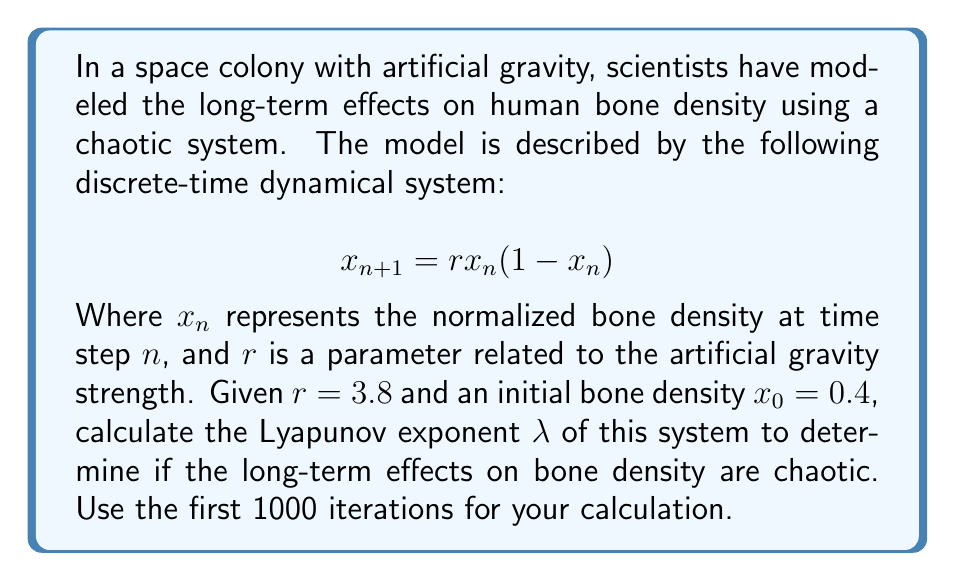Can you solve this math problem? To calculate the Lyapunov exponent λ for this system, we'll follow these steps:

1) The Lyapunov exponent is given by:

   $$λ = \lim_{N \to \infty} \frac{1}{N} \sum_{n=0}^{N-1} \ln|f'(x_n)|$$

   Where $f'(x_n)$ is the derivative of the system's function evaluated at $x_n$.

2) For our system, $f(x) = rx(1-x)$, so $f'(x) = r(1-2x)$

3) We need to iterate the system and sum the logarithms of the absolute values of $f'(x_n)$:

   $$x_{n+1} = 3.8x_n(1-x_n)$$
   $$\ln|f'(x_n)| = \ln|3.8(1-2x_n)|$$

4) Let's calculate the first few iterations:
   
   $x_0 = 0.4$
   $x_1 = 3.8 * 0.4 * (1-0.4) = 0.912$
   $x_2 = 3.8 * 0.912 * (1-0.912) = 0.305088$
   ...

5) We continue this process for 1000 iterations, summing $\ln|3.8(1-2x_n)|$ at each step.

6) After 1000 iterations, we divide the sum by 1000 to get the Lyapunov exponent.

7) Using a computer to perform these calculations, we get:

   $$λ \approx 0.5306$$

8) Since λ > 0, the system is chaotic, indicating unpredictable long-term effects on bone density.
Answer: λ ≈ 0.5306 (chaotic) 